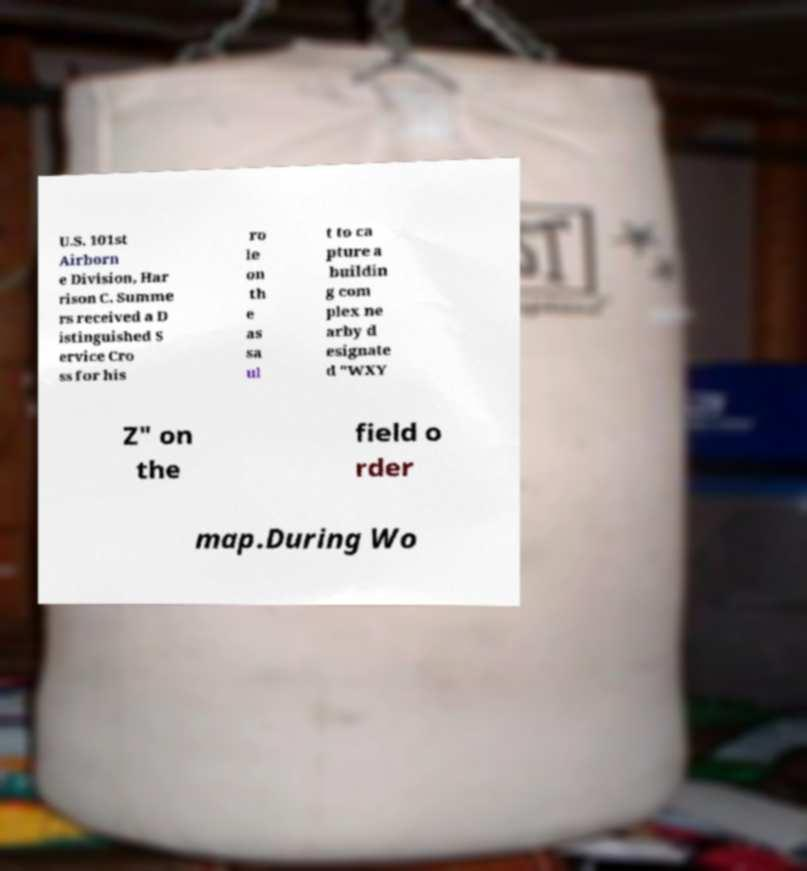There's text embedded in this image that I need extracted. Can you transcribe it verbatim? U.S. 101st Airborn e Division, Har rison C. Summe rs received a D istinguished S ervice Cro ss for his ro le on th e as sa ul t to ca pture a buildin g com plex ne arby d esignate d "WXY Z" on the field o rder map.During Wo 